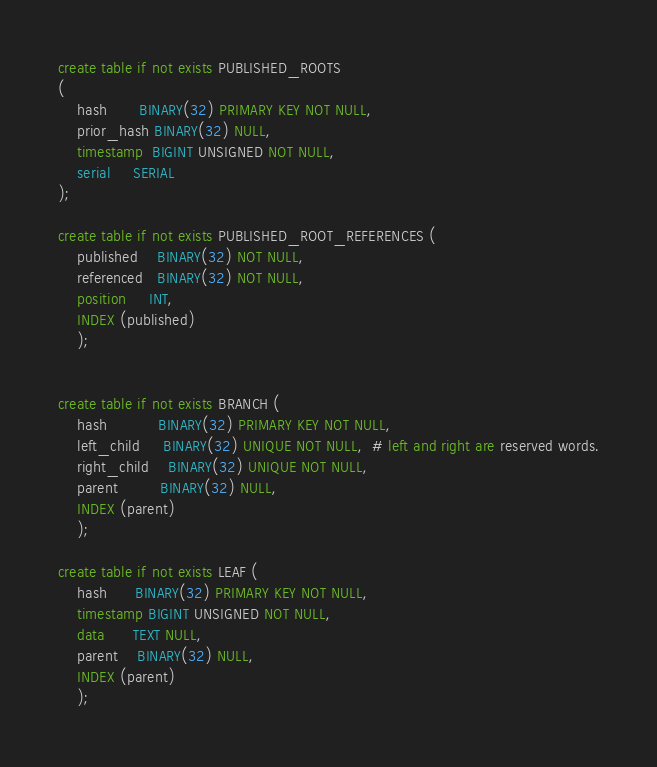<code> <loc_0><loc_0><loc_500><loc_500><_SQL_>

create table if not exists PUBLISHED_ROOTS
(
    hash       BINARY(32) PRIMARY KEY NOT NULL,
    prior_hash BINARY(32) NULL,
    timestamp  BIGINT UNSIGNED NOT NULL,
    serial     SERIAL
);

create table if not exists PUBLISHED_ROOT_REFERENCES (
    published    BINARY(32) NOT NULL,
    referenced   BINARY(32) NOT NULL,
    position     INT,
    INDEX (published)
    );


create table if not exists BRANCH (
    hash           BINARY(32) PRIMARY KEY NOT NULL,
    left_child     BINARY(32) UNIQUE NOT NULL,  # left and right are reserved words.
    right_child    BINARY(32) UNIQUE NOT NULL,
    parent         BINARY(32) NULL,
    INDEX (parent)
    );

create table if not exists LEAF (
    hash      BINARY(32) PRIMARY KEY NOT NULL,
    timestamp BIGINT UNSIGNED NOT NULL,
    data      TEXT NULL,
    parent    BINARY(32) NULL,
    INDEX (parent)
    );</code> 